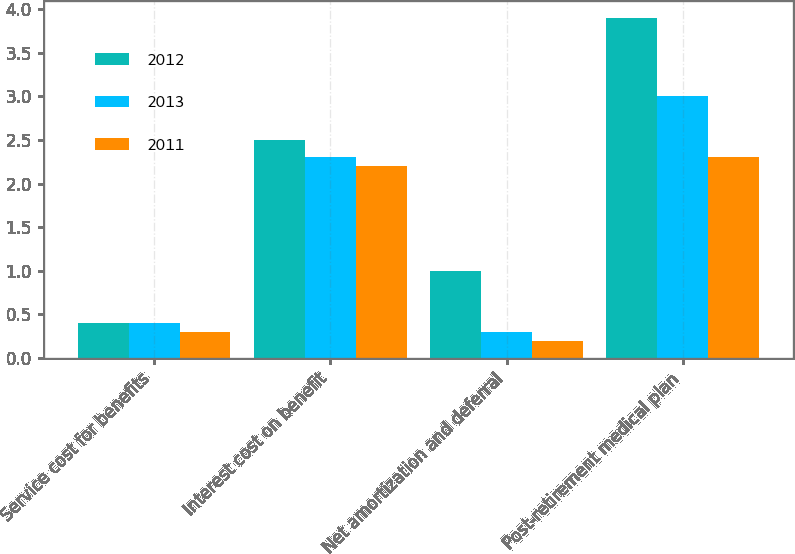Convert chart. <chart><loc_0><loc_0><loc_500><loc_500><stacked_bar_chart><ecel><fcel>Service cost for benefits<fcel>Interest cost on benefit<fcel>Net amortization and deferral<fcel>Post-retirement medical plan<nl><fcel>2012<fcel>0.4<fcel>2.5<fcel>1<fcel>3.9<nl><fcel>2013<fcel>0.4<fcel>2.3<fcel>0.3<fcel>3<nl><fcel>2011<fcel>0.3<fcel>2.2<fcel>0.2<fcel>2.3<nl></chart> 